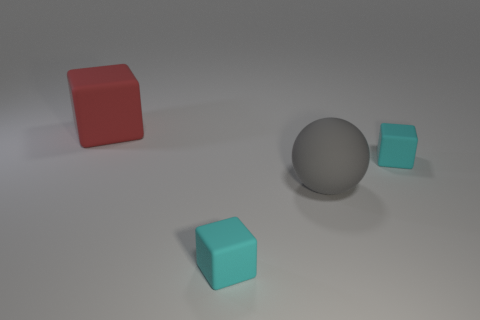Subtract all tiny cyan blocks. How many blocks are left? 1 Add 4 big blocks. How many objects exist? 8 Subtract all red blocks. How many blocks are left? 2 Subtract all blue cylinders. How many cyan cubes are left? 2 Subtract 2 blocks. How many blocks are left? 1 Subtract all small cyan rubber cylinders. Subtract all red matte things. How many objects are left? 3 Add 2 large gray matte things. How many large gray matte things are left? 3 Add 2 small red rubber things. How many small red rubber things exist? 2 Subtract 0 blue blocks. How many objects are left? 4 Subtract all blocks. How many objects are left? 1 